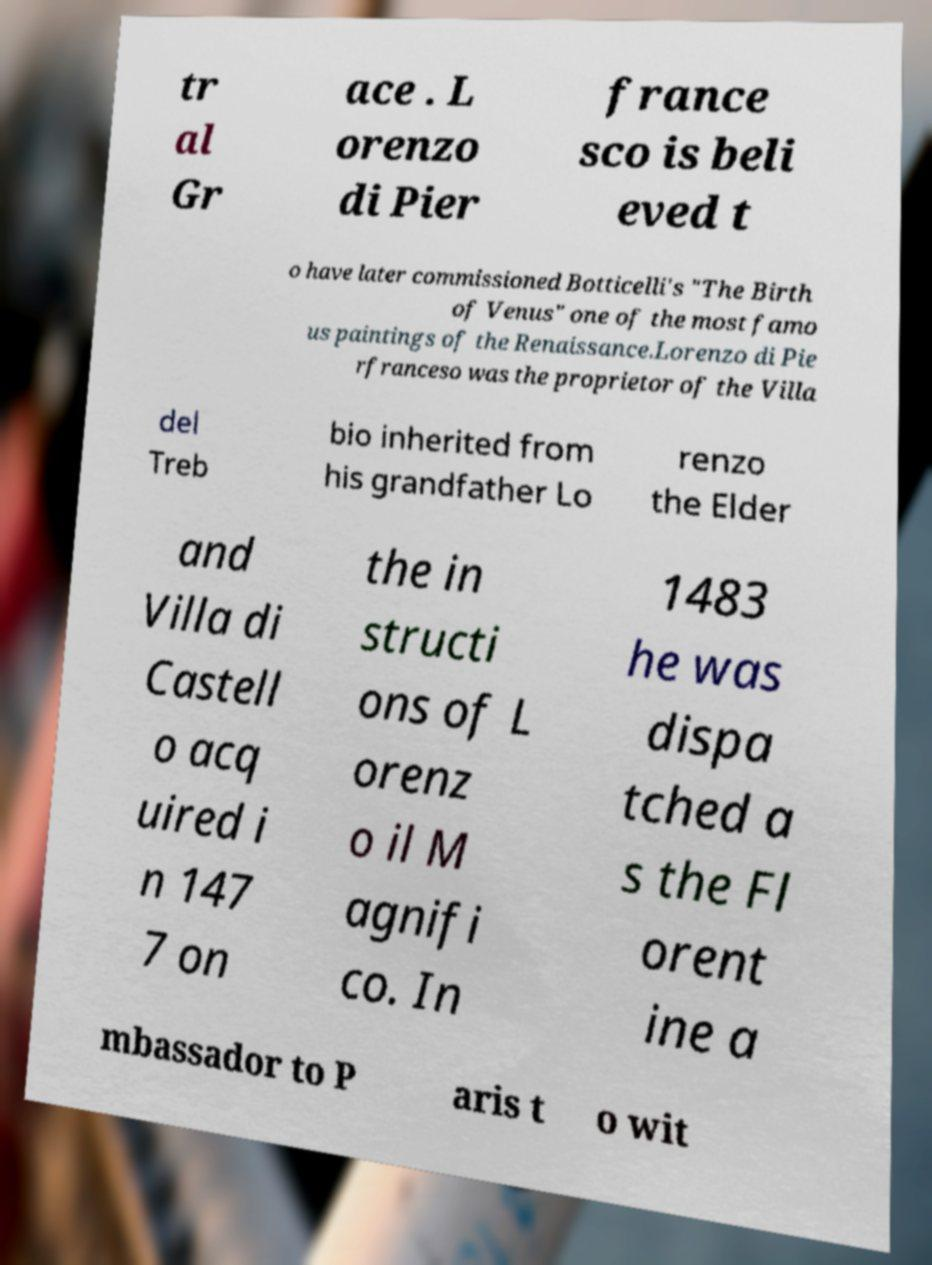Could you assist in decoding the text presented in this image and type it out clearly? tr al Gr ace . L orenzo di Pier france sco is beli eved t o have later commissioned Botticelli's "The Birth of Venus" one of the most famo us paintings of the Renaissance.Lorenzo di Pie rfranceso was the proprietor of the Villa del Treb bio inherited from his grandfather Lo renzo the Elder and Villa di Castell o acq uired i n 147 7 on the in structi ons of L orenz o il M agnifi co. In 1483 he was dispa tched a s the Fl orent ine a mbassador to P aris t o wit 